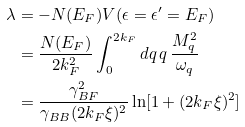<formula> <loc_0><loc_0><loc_500><loc_500>\lambda & = - N ( E _ { F } ) V ( \epsilon = \epsilon ^ { \prime } = E _ { F } ) \\ & = \frac { N ( E _ { F } ) } { 2 k _ { F } ^ { 2 } } \int _ { 0 } ^ { 2 k _ { F } } d q \, q \, \frac { M _ { q } ^ { 2 } } { \omega _ { q } } \\ & = \frac { \gamma _ { B F } ^ { 2 } } { \gamma _ { B B } ( 2 k _ { F } \xi ) ^ { 2 } } \ln [ 1 + ( 2 k _ { F } \xi ) ^ { 2 } ]</formula> 